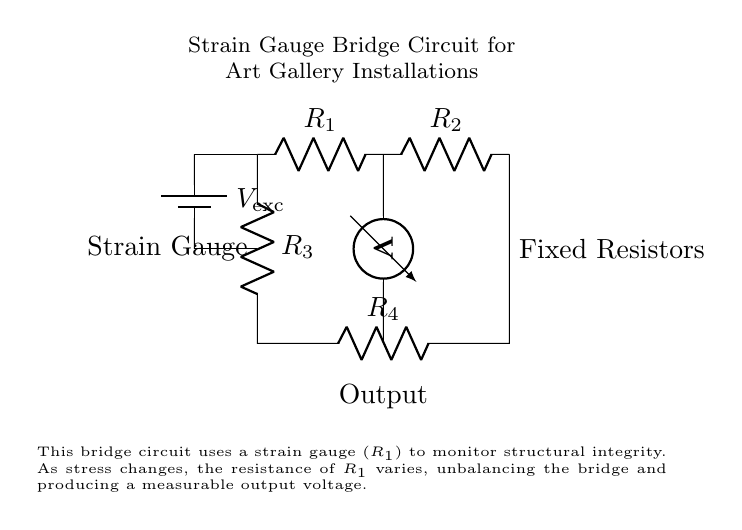What type of circuit is shown? The circuit shown is a bridge circuit, specifically a strain gauge bridge circuit designed for monitoring.
Answer: bridge circuit What does R1 represent? R1 represents the strain gauge used for monitoring structural integrity in the installation.
Answer: strain gauge What is the purpose of the voltmeter in this circuit? The voltmeter is used to measure the output voltage of the bridge circuit, indicating the balance of the resistances due to the strain gauge's response to stress.
Answer: measure output voltage How many resistors are in this bridge circuit? There are four resistors in total, including the strain gauge and three fixed resistors.
Answer: four What happens to the output voltage if the strain gauge (R1) experiences an increase in stress? As the stress increases, the resistance of R1 increases, causing an unbalance in the bridge and resulting in an increase in the output voltage.
Answer: increases What is the voltage source labeled as? The voltage source is labeled as V_exe, which represents the excitation voltage applied to the circuit.
Answer: V_exc 